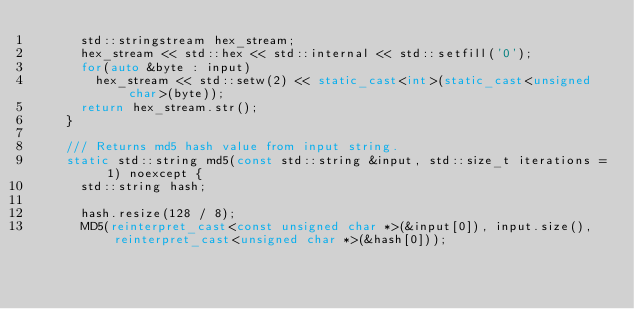<code> <loc_0><loc_0><loc_500><loc_500><_C++_>      std::stringstream hex_stream;
      hex_stream << std::hex << std::internal << std::setfill('0');
      for(auto &byte : input)
        hex_stream << std::setw(2) << static_cast<int>(static_cast<unsigned char>(byte));
      return hex_stream.str();
    }

    /// Returns md5 hash value from input string.
    static std::string md5(const std::string &input, std::size_t iterations = 1) noexcept {
      std::string hash;

      hash.resize(128 / 8);
      MD5(reinterpret_cast<const unsigned char *>(&input[0]), input.size(), reinterpret_cast<unsigned char *>(&hash[0]));
</code> 